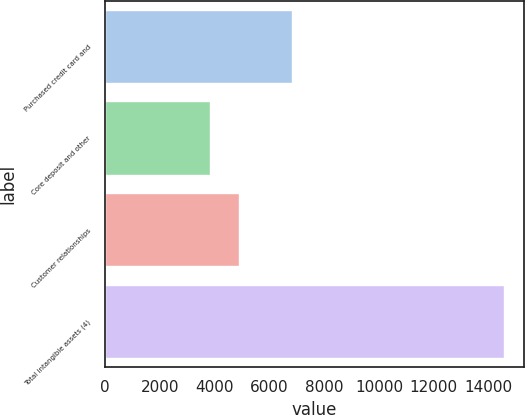Convert chart to OTSL. <chart><loc_0><loc_0><loc_500><loc_500><bar_chart><fcel>Purchased credit card and<fcel>Core deposit and other<fcel>Customer relationships<fcel>Total intangible assets (4)<nl><fcel>6830<fcel>3836<fcel>4907.7<fcel>14553<nl></chart> 